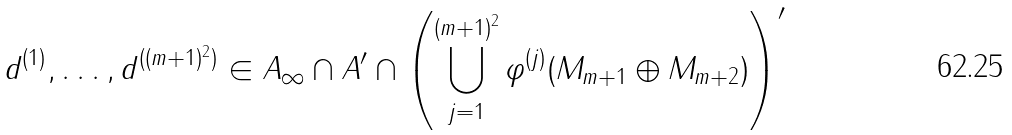<formula> <loc_0><loc_0><loc_500><loc_500>d ^ { ( 1 ) } , \dots , d ^ { ( ( m + 1 ) ^ { 2 } ) } \in A _ { \infty } \cap A ^ { \prime } \cap \left ( \bigcup _ { j = 1 } ^ { ( m + 1 ) ^ { 2 } } \varphi ^ { ( j ) } ( M _ { m + 1 } \oplus M _ { m + 2 } ) \right ) ^ { \prime }</formula> 